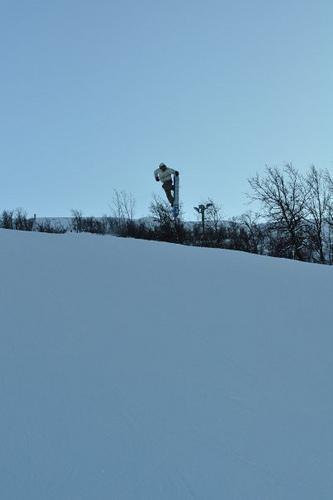How many giraffes are in the picture?
Give a very brief answer. 0. 